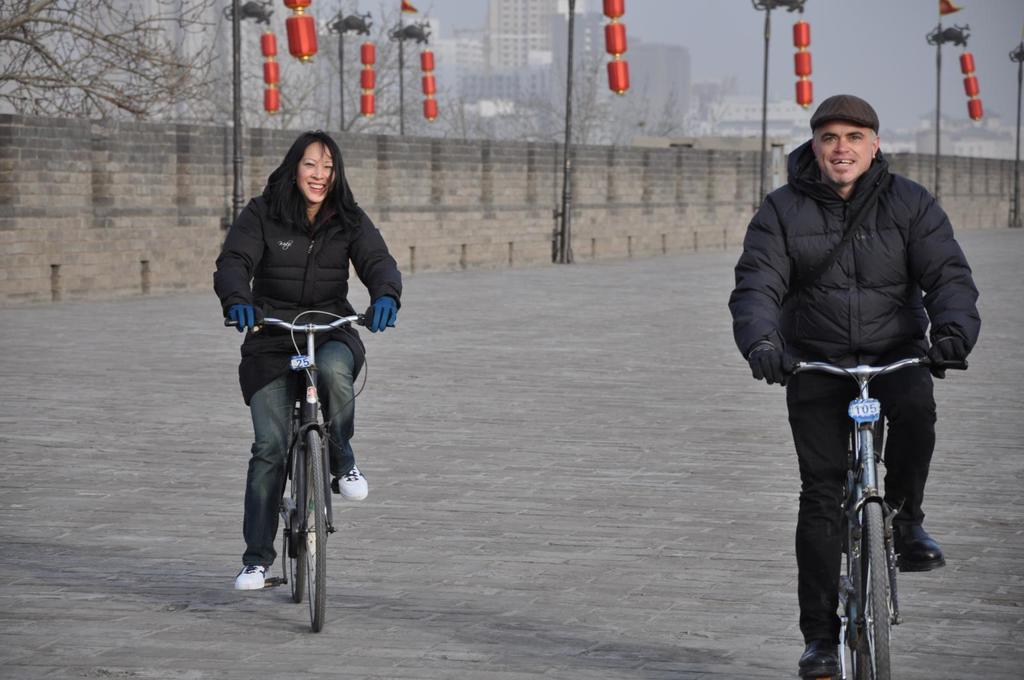How many people are in the image? There are two people in the image, a woman and a man. What are the woman and the man doing in the image? The woman and the man are on a cycle. What expressions do the woman and the man have in the image? The woman and the man are both smiling. What can be seen in the background of the image? There is a wall, poles, trees, and buildings in the background of the image. What type of wire can be seen connecting the harbor to the song in the image? There is no wire, harbor, or song present in the image. 